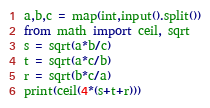Convert code to text. <code><loc_0><loc_0><loc_500><loc_500><_Python_>a,b,c = map(int,input().split())
from math import ceil, sqrt 
s = sqrt(a*b/c)
t = sqrt(a*c/b)
r = sqrt(b*c/a)
print(ceil(4*(s+t+r)))</code> 